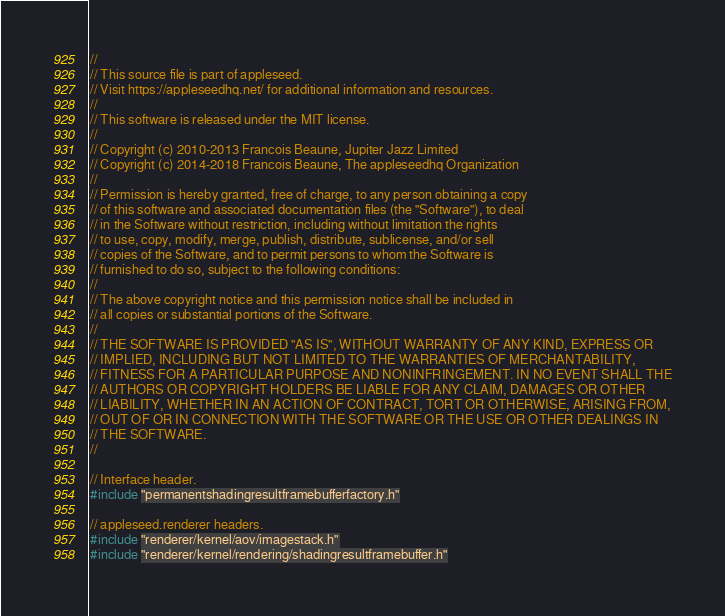Convert code to text. <code><loc_0><loc_0><loc_500><loc_500><_C++_>
//
// This source file is part of appleseed.
// Visit https://appleseedhq.net/ for additional information and resources.
//
// This software is released under the MIT license.
//
// Copyright (c) 2010-2013 Francois Beaune, Jupiter Jazz Limited
// Copyright (c) 2014-2018 Francois Beaune, The appleseedhq Organization
//
// Permission is hereby granted, free of charge, to any person obtaining a copy
// of this software and associated documentation files (the "Software"), to deal
// in the Software without restriction, including without limitation the rights
// to use, copy, modify, merge, publish, distribute, sublicense, and/or sell
// copies of the Software, and to permit persons to whom the Software is
// furnished to do so, subject to the following conditions:
//
// The above copyright notice and this permission notice shall be included in
// all copies or substantial portions of the Software.
//
// THE SOFTWARE IS PROVIDED "AS IS", WITHOUT WARRANTY OF ANY KIND, EXPRESS OR
// IMPLIED, INCLUDING BUT NOT LIMITED TO THE WARRANTIES OF MERCHANTABILITY,
// FITNESS FOR A PARTICULAR PURPOSE AND NONINFRINGEMENT. IN NO EVENT SHALL THE
// AUTHORS OR COPYRIGHT HOLDERS BE LIABLE FOR ANY CLAIM, DAMAGES OR OTHER
// LIABILITY, WHETHER IN AN ACTION OF CONTRACT, TORT OR OTHERWISE, ARISING FROM,
// OUT OF OR IN CONNECTION WITH THE SOFTWARE OR THE USE OR OTHER DEALINGS IN
// THE SOFTWARE.
//

// Interface header.
#include "permanentshadingresultframebufferfactory.h"

// appleseed.renderer headers.
#include "renderer/kernel/aov/imagestack.h"
#include "renderer/kernel/rendering/shadingresultframebuffer.h"</code> 